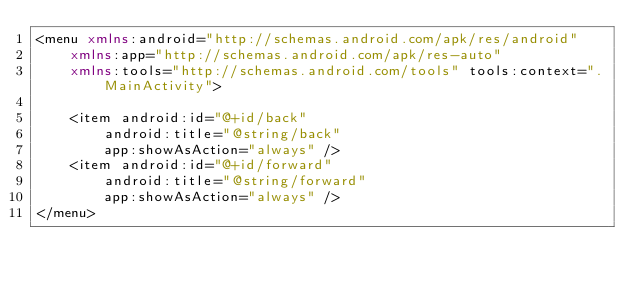<code> <loc_0><loc_0><loc_500><loc_500><_XML_><menu xmlns:android="http://schemas.android.com/apk/res/android"
    xmlns:app="http://schemas.android.com/apk/res-auto"
    xmlns:tools="http://schemas.android.com/tools" tools:context=".MainActivity">

    <item android:id="@+id/back"
        android:title="@string/back"
        app:showAsAction="always" />
    <item android:id="@+id/forward"
        android:title="@string/forward"
        app:showAsAction="always" />
</menu>
</code> 